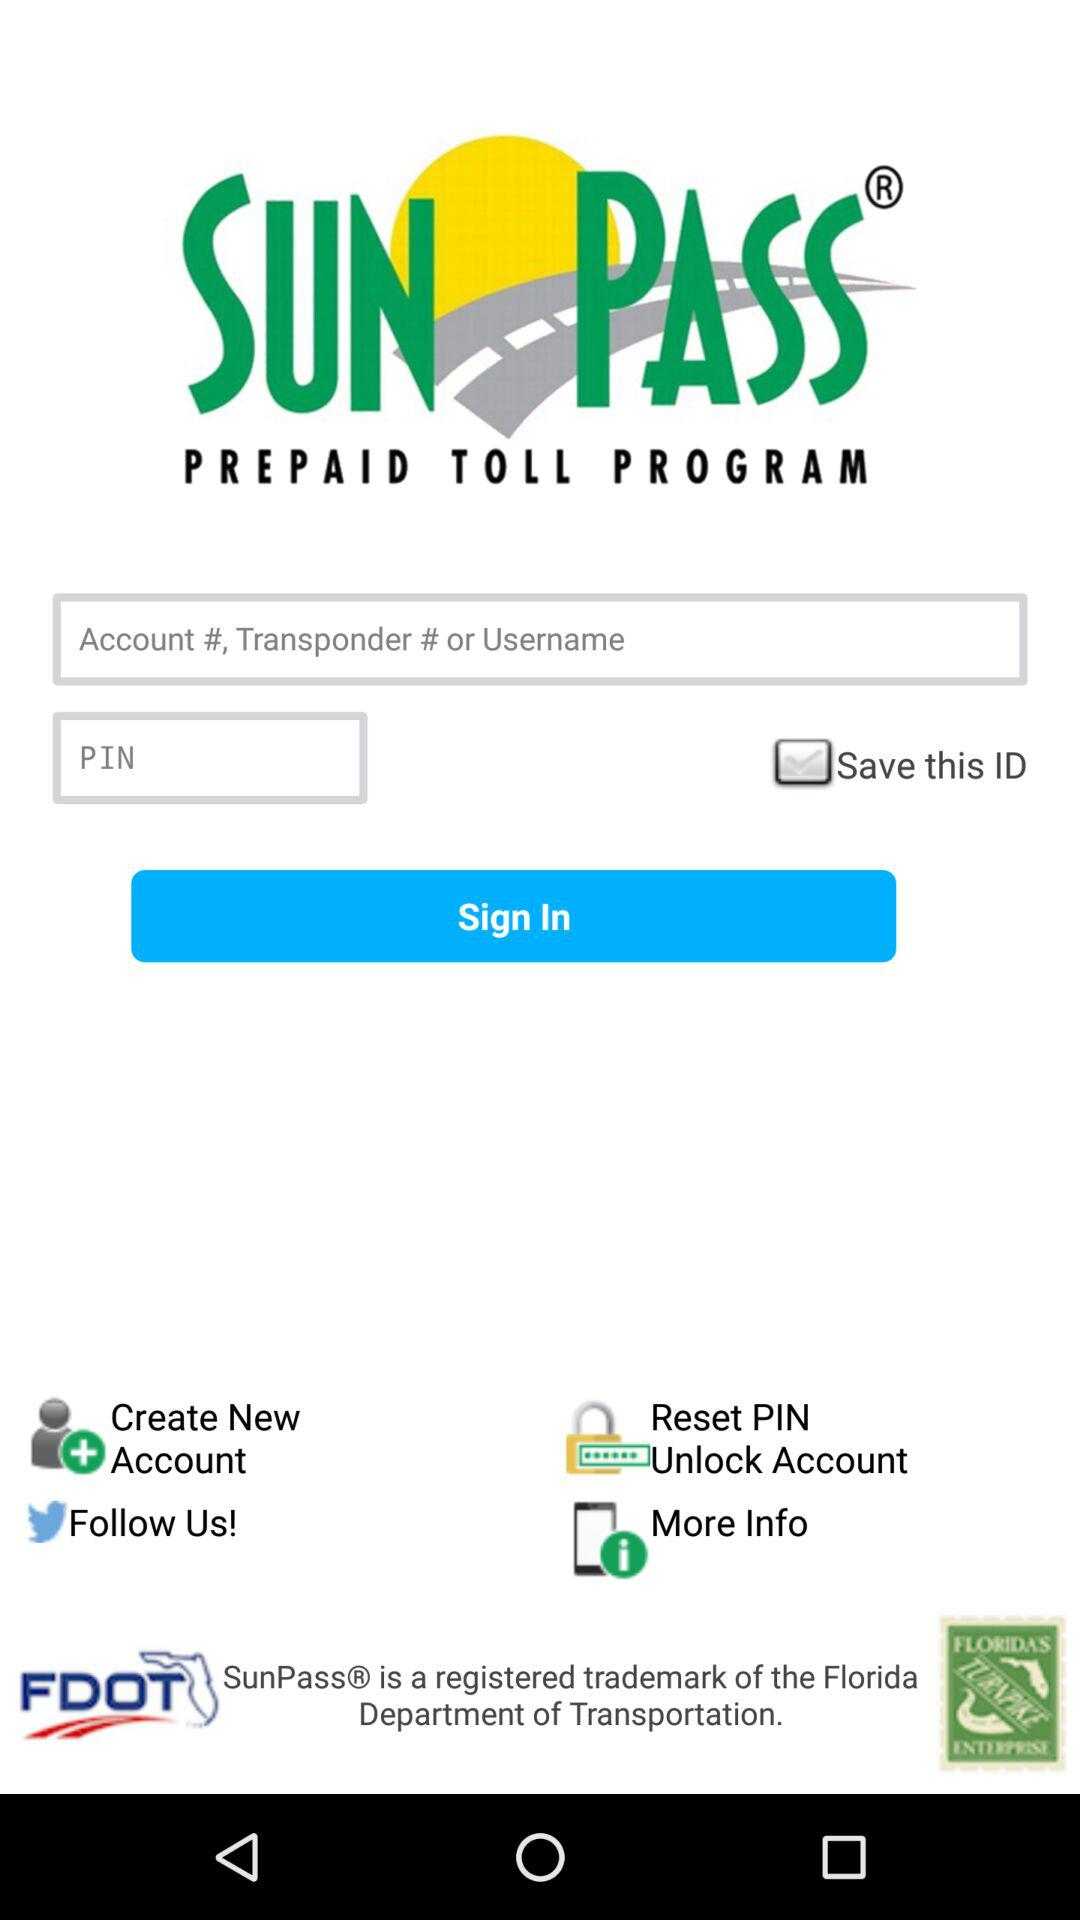What is the status of "Save this ID"? The status is "on". 